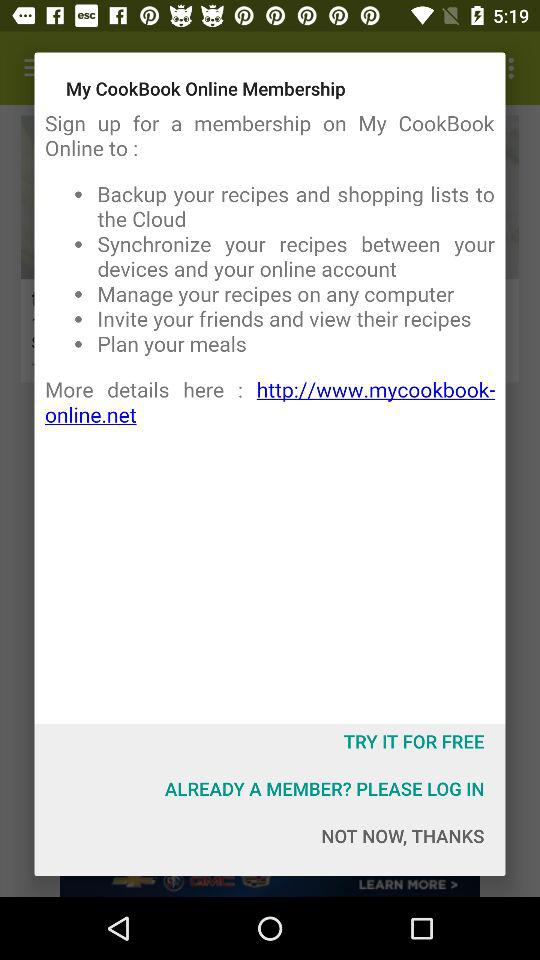What is the email address?
When the provided information is insufficient, respond with <no answer>. <no answer> 